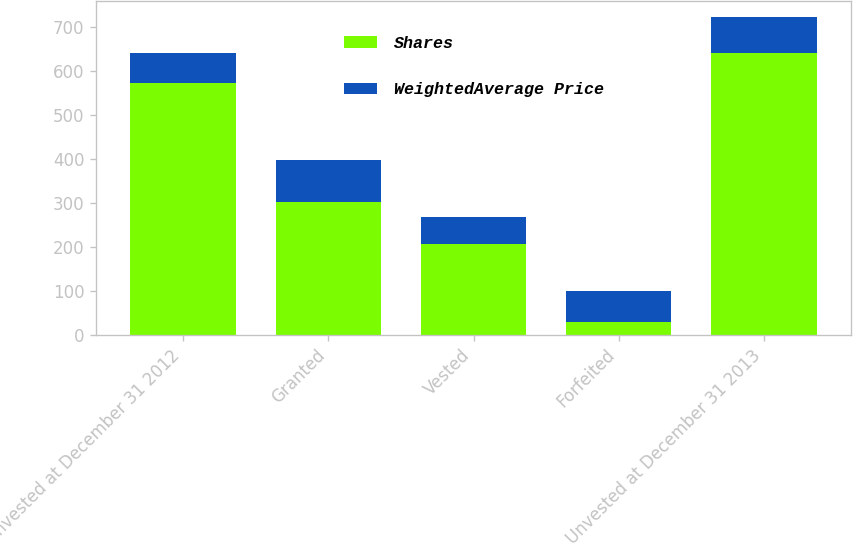Convert chart to OTSL. <chart><loc_0><loc_0><loc_500><loc_500><stacked_bar_chart><ecel><fcel>Unvested at December 31 2012<fcel>Granted<fcel>Vested<fcel>Forfeited<fcel>Unvested at December 31 2013<nl><fcel>Shares<fcel>574<fcel>303<fcel>207<fcel>28<fcel>642<nl><fcel>WeightedAverage Price<fcel>67.28<fcel>94.74<fcel>60.65<fcel>72.27<fcel>82.16<nl></chart> 